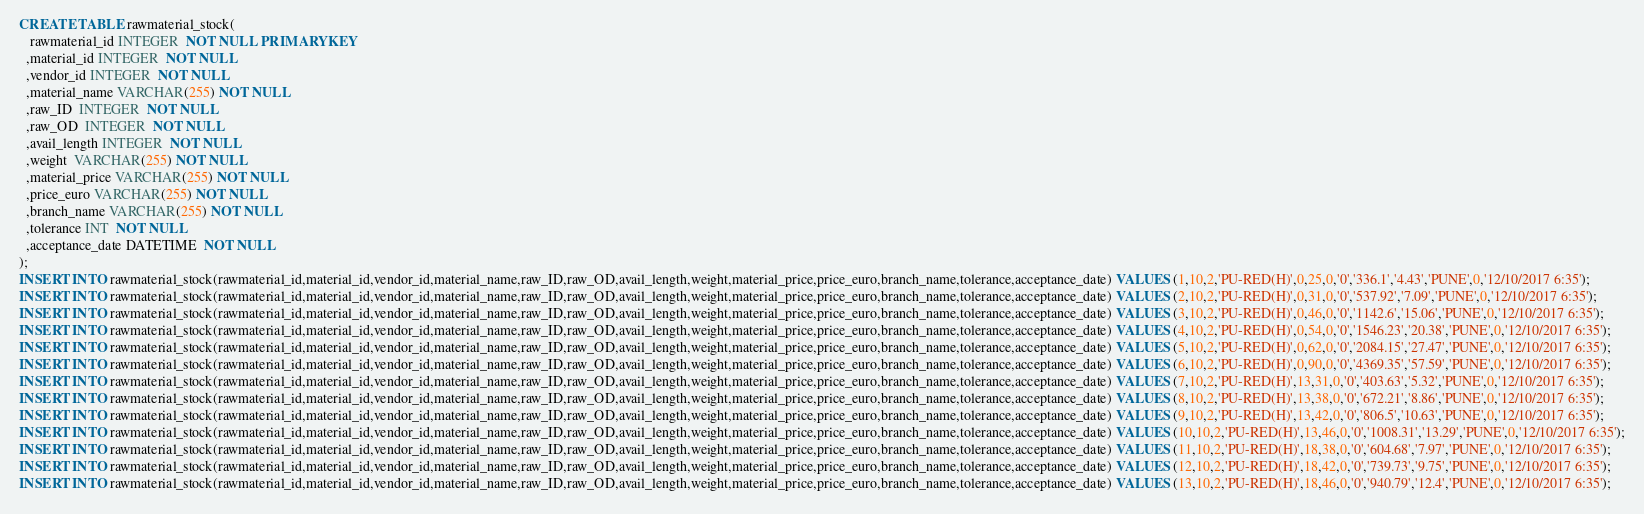<code> <loc_0><loc_0><loc_500><loc_500><_SQL_>CREATE TABLE rawmaterial_stock(
   rawmaterial_id INTEGER  NOT NULL PRIMARY KEY 
  ,material_id INTEGER  NOT NULL
  ,vendor_id INTEGER  NOT NULL
  ,material_name VARCHAR(255) NOT NULL
  ,raw_ID  INTEGER  NOT NULL
  ,raw_OD  INTEGER  NOT NULL
  ,avail_length INTEGER  NOT NULL
  ,weight  VARCHAR(255) NOT NULL
  ,material_price VARCHAR(255) NOT NULL
  ,price_euro VARCHAR(255) NOT NULL
  ,branch_name VARCHAR(255) NOT NULL
  ,tolerance INT  NOT NULL
  ,acceptance_date DATETIME  NOT NULL
);
INSERT INTO rawmaterial_stock(rawmaterial_id,material_id,vendor_id,material_name,raw_ID,raw_OD,avail_length,weight,material_price,price_euro,branch_name,tolerance,acceptance_date) VALUES (1,10,2,'PU-RED(H)',0,25,0,'0','336.1','4.43','PUNE',0,'12/10/2017 6:35');
INSERT INTO rawmaterial_stock(rawmaterial_id,material_id,vendor_id,material_name,raw_ID,raw_OD,avail_length,weight,material_price,price_euro,branch_name,tolerance,acceptance_date) VALUES (2,10,2,'PU-RED(H)',0,31,0,'0','537.92','7.09','PUNE',0,'12/10/2017 6:35');
INSERT INTO rawmaterial_stock(rawmaterial_id,material_id,vendor_id,material_name,raw_ID,raw_OD,avail_length,weight,material_price,price_euro,branch_name,tolerance,acceptance_date) VALUES (3,10,2,'PU-RED(H)',0,46,0,'0','1142.6','15.06','PUNE',0,'12/10/2017 6:35');
INSERT INTO rawmaterial_stock(rawmaterial_id,material_id,vendor_id,material_name,raw_ID,raw_OD,avail_length,weight,material_price,price_euro,branch_name,tolerance,acceptance_date) VALUES (4,10,2,'PU-RED(H)',0,54,0,'0','1546.23','20.38','PUNE',0,'12/10/2017 6:35');
INSERT INTO rawmaterial_stock(rawmaterial_id,material_id,vendor_id,material_name,raw_ID,raw_OD,avail_length,weight,material_price,price_euro,branch_name,tolerance,acceptance_date) VALUES (5,10,2,'PU-RED(H)',0,62,0,'0','2084.15','27.47','PUNE',0,'12/10/2017 6:35');
INSERT INTO rawmaterial_stock(rawmaterial_id,material_id,vendor_id,material_name,raw_ID,raw_OD,avail_length,weight,material_price,price_euro,branch_name,tolerance,acceptance_date) VALUES (6,10,2,'PU-RED(H)',0,90,0,'0','4369.35','57.59','PUNE',0,'12/10/2017 6:35');
INSERT INTO rawmaterial_stock(rawmaterial_id,material_id,vendor_id,material_name,raw_ID,raw_OD,avail_length,weight,material_price,price_euro,branch_name,tolerance,acceptance_date) VALUES (7,10,2,'PU-RED(H)',13,31,0,'0','403.63','5.32','PUNE',0,'12/10/2017 6:35');
INSERT INTO rawmaterial_stock(rawmaterial_id,material_id,vendor_id,material_name,raw_ID,raw_OD,avail_length,weight,material_price,price_euro,branch_name,tolerance,acceptance_date) VALUES (8,10,2,'PU-RED(H)',13,38,0,'0','672.21','8.86','PUNE',0,'12/10/2017 6:35');
INSERT INTO rawmaterial_stock(rawmaterial_id,material_id,vendor_id,material_name,raw_ID,raw_OD,avail_length,weight,material_price,price_euro,branch_name,tolerance,acceptance_date) VALUES (9,10,2,'PU-RED(H)',13,42,0,'0','806.5','10.63','PUNE',0,'12/10/2017 6:35');
INSERT INTO rawmaterial_stock(rawmaterial_id,material_id,vendor_id,material_name,raw_ID,raw_OD,avail_length,weight,material_price,price_euro,branch_name,tolerance,acceptance_date) VALUES (10,10,2,'PU-RED(H)',13,46,0,'0','1008.31','13.29','PUNE',0,'12/10/2017 6:35');
INSERT INTO rawmaterial_stock(rawmaterial_id,material_id,vendor_id,material_name,raw_ID,raw_OD,avail_length,weight,material_price,price_euro,branch_name,tolerance,acceptance_date) VALUES (11,10,2,'PU-RED(H)',18,38,0,'0','604.68','7.97','PUNE',0,'12/10/2017 6:35');
INSERT INTO rawmaterial_stock(rawmaterial_id,material_id,vendor_id,material_name,raw_ID,raw_OD,avail_length,weight,material_price,price_euro,branch_name,tolerance,acceptance_date) VALUES (12,10,2,'PU-RED(H)',18,42,0,'0','739.73','9.75','PUNE',0,'12/10/2017 6:35');
INSERT INTO rawmaterial_stock(rawmaterial_id,material_id,vendor_id,material_name,raw_ID,raw_OD,avail_length,weight,material_price,price_euro,branch_name,tolerance,acceptance_date) VALUES (13,10,2,'PU-RED(H)',18,46,0,'0','940.79','12.4','PUNE',0,'12/10/2017 6:35');</code> 